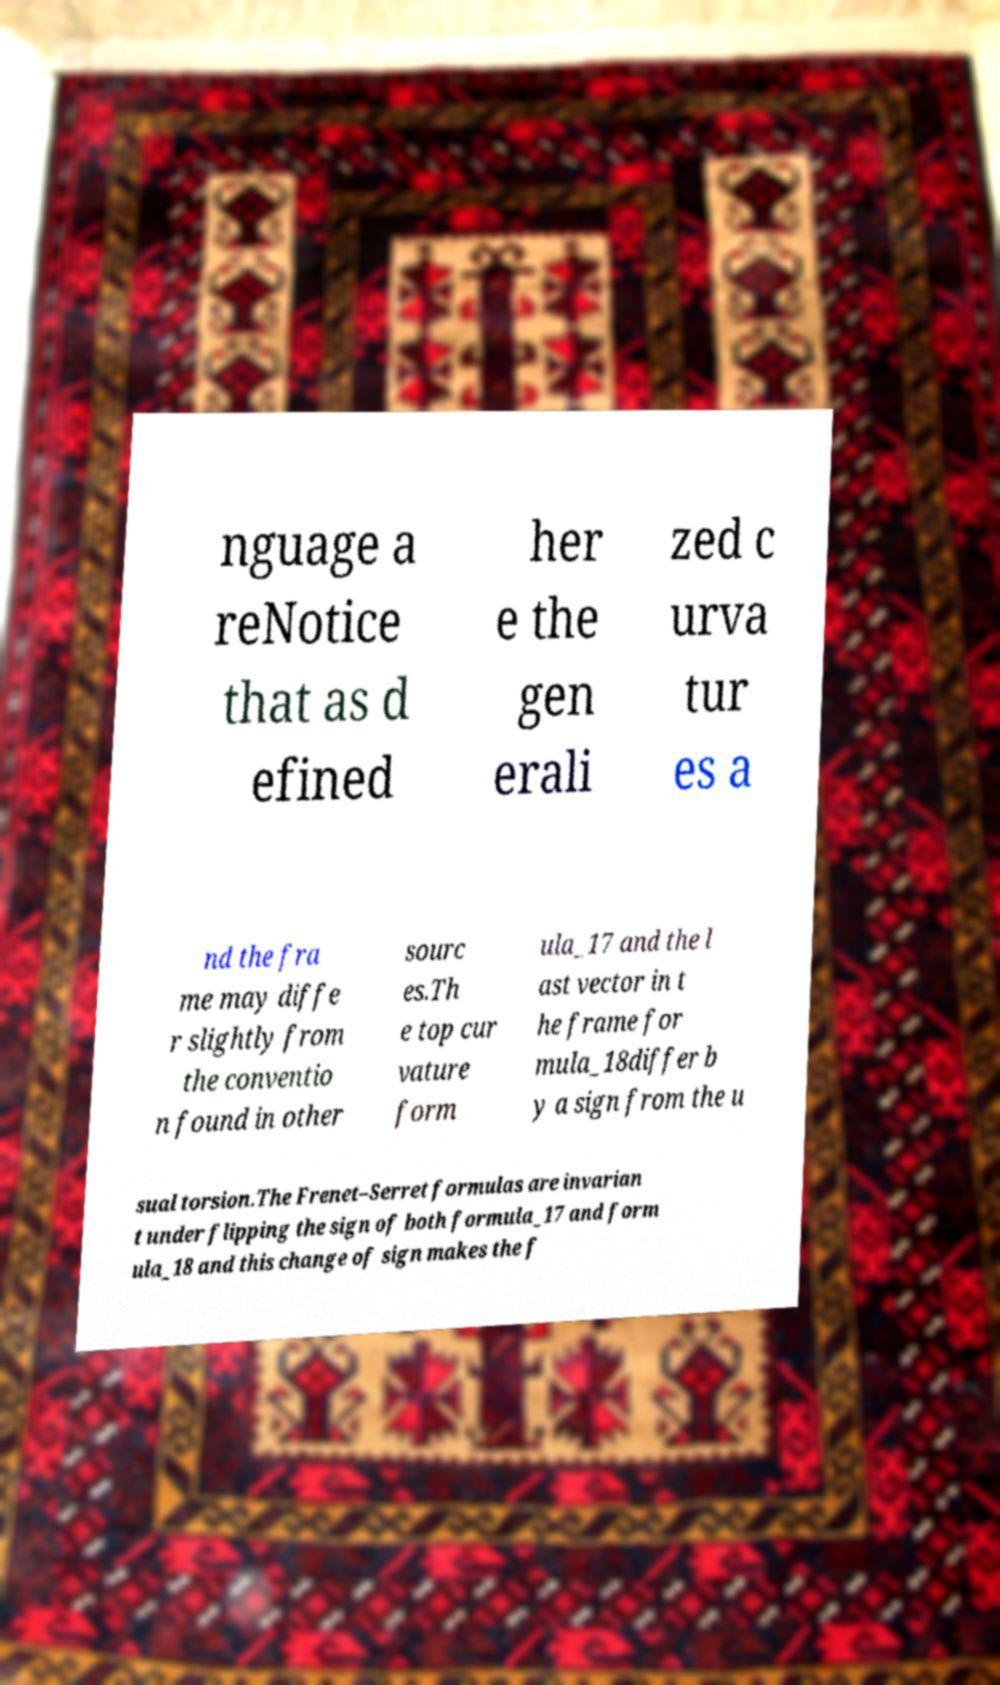For documentation purposes, I need the text within this image transcribed. Could you provide that? nguage a reNotice that as d efined her e the gen erali zed c urva tur es a nd the fra me may diffe r slightly from the conventio n found in other sourc es.Th e top cur vature form ula_17 and the l ast vector in t he frame for mula_18differ b y a sign from the u sual torsion.The Frenet–Serret formulas are invarian t under flipping the sign of both formula_17 and form ula_18 and this change of sign makes the f 